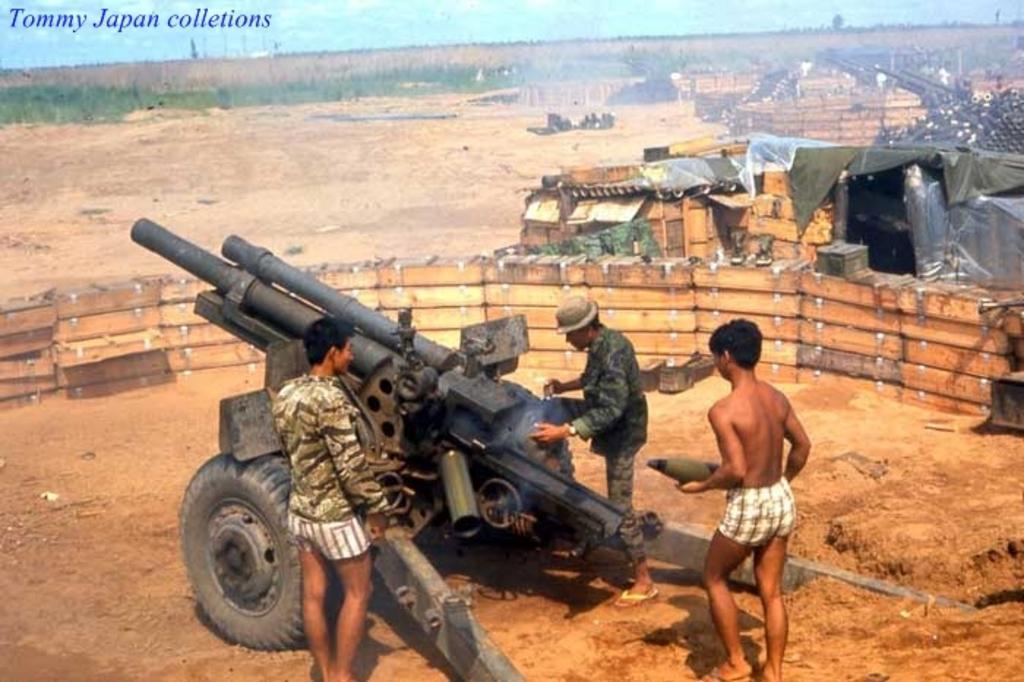How would you summarize this image in a sentence or two? There are two persons standing near a missile system, which is near a person who is holding a bullet and walking on the ground. Around this missile system, there is a wooden wall, which is near tent and other objects. In the background, there are vehicles, there is grass on the ground, there are trees, there is watermark and there are clouds in the blue sky. 